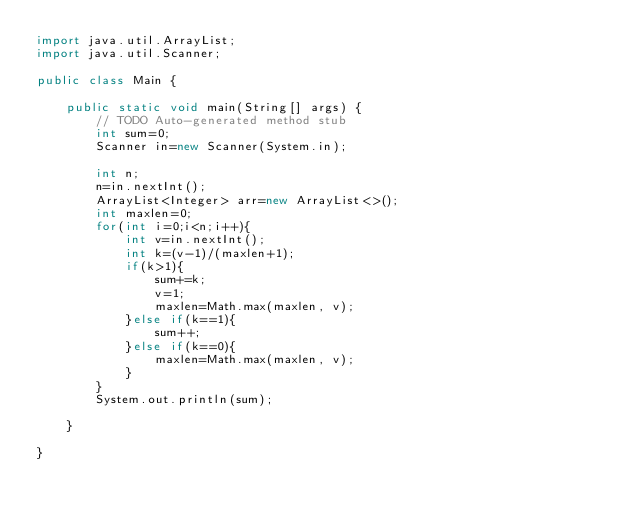<code> <loc_0><loc_0><loc_500><loc_500><_Java_>import java.util.ArrayList;
import java.util.Scanner;

public class Main {

	public static void main(String[] args) {
		// TODO Auto-generated method stub
		int sum=0;
		Scanner in=new Scanner(System.in);
		
		int n;
		n=in.nextInt();
		ArrayList<Integer> arr=new ArrayList<>();
		int maxlen=0;
		for(int i=0;i<n;i++){
			int v=in.nextInt();
			int k=(v-1)/(maxlen+1);
			if(k>1){
				sum+=k;
				v=1;
				maxlen=Math.max(maxlen, v);
			}else if(k==1){
				sum++;
			}else if(k==0){
				maxlen=Math.max(maxlen, v);
			}
		}
		System.out.println(sum);

	}

}
</code> 